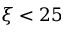<formula> <loc_0><loc_0><loc_500><loc_500>\xi < 2 5</formula> 